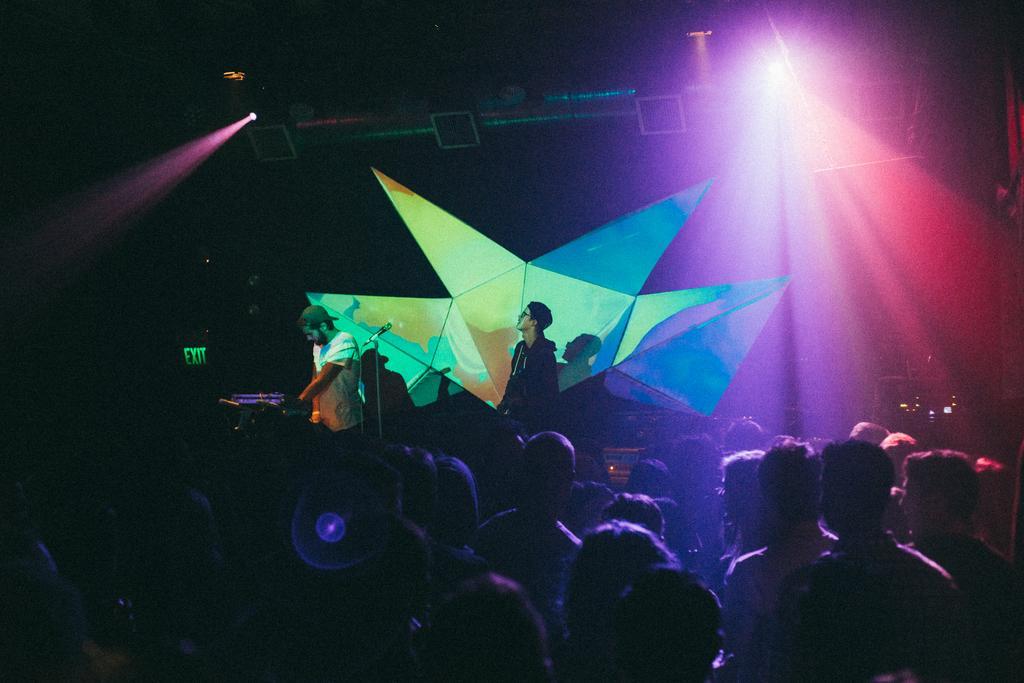Could you give a brief overview of what you see in this image? In this picture I can see group of people, there are two persons standing, there is a mike with a mike stand, there are focus lights and a board. 